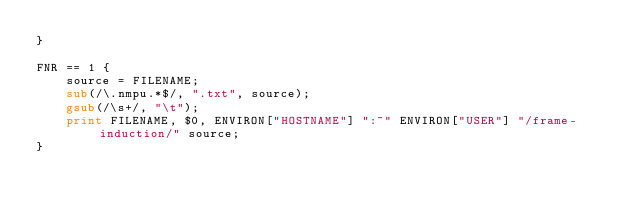<code> <loc_0><loc_0><loc_500><loc_500><_Awk_>}

FNR == 1 {
    source = FILENAME;
    sub(/\.nmpu.*$/, ".txt", source);
    gsub(/\s+/, "\t");
    print FILENAME, $0, ENVIRON["HOSTNAME"] ":~" ENVIRON["USER"] "/frame-induction/" source;
}
</code> 